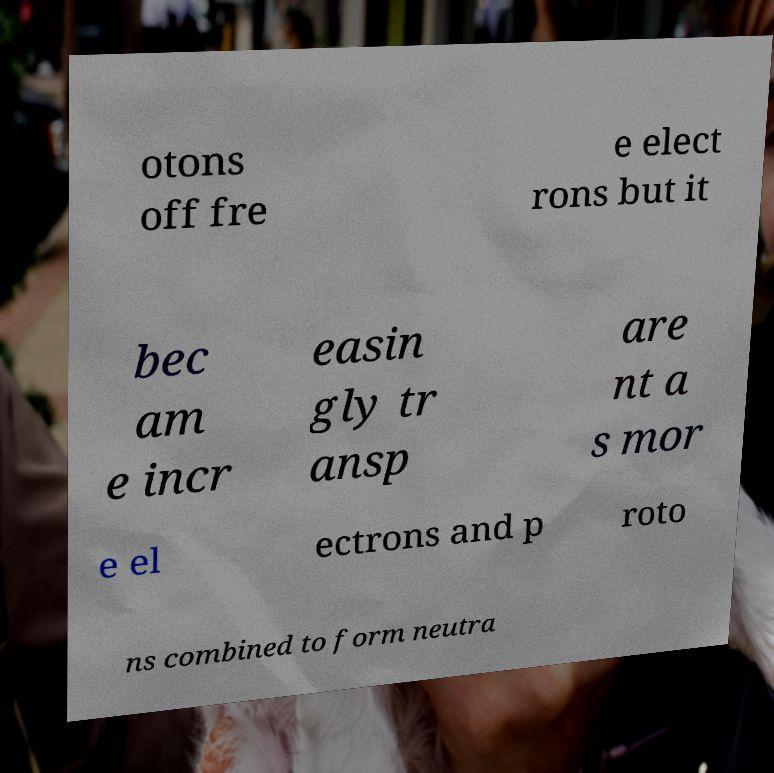Can you accurately transcribe the text from the provided image for me? otons off fre e elect rons but it bec am e incr easin gly tr ansp are nt a s mor e el ectrons and p roto ns combined to form neutra 